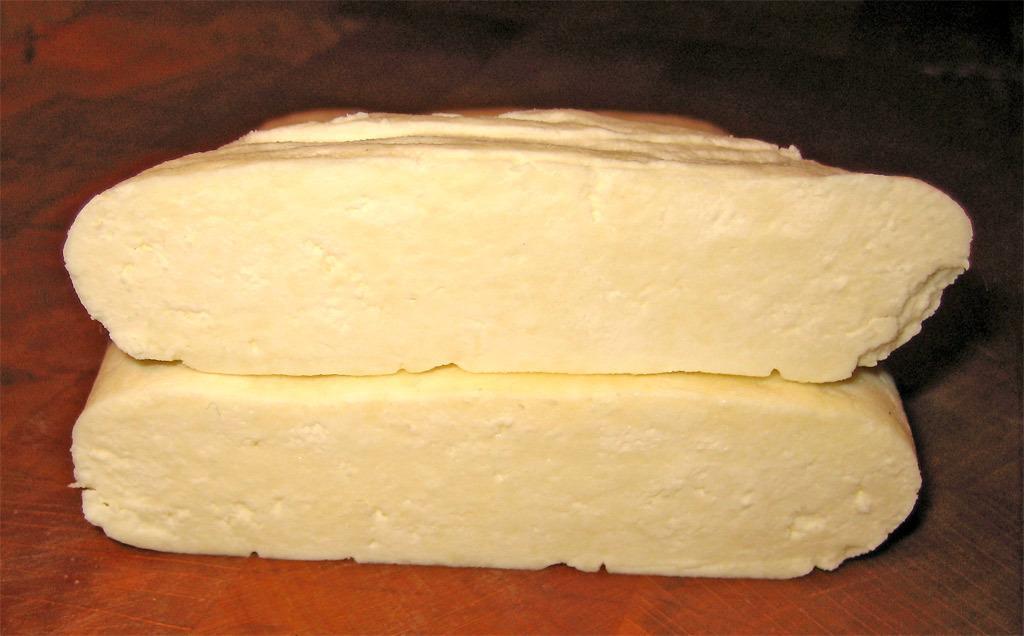In one or two sentences, can you explain what this image depicts? In the picture we can see two bread slices on the table. 